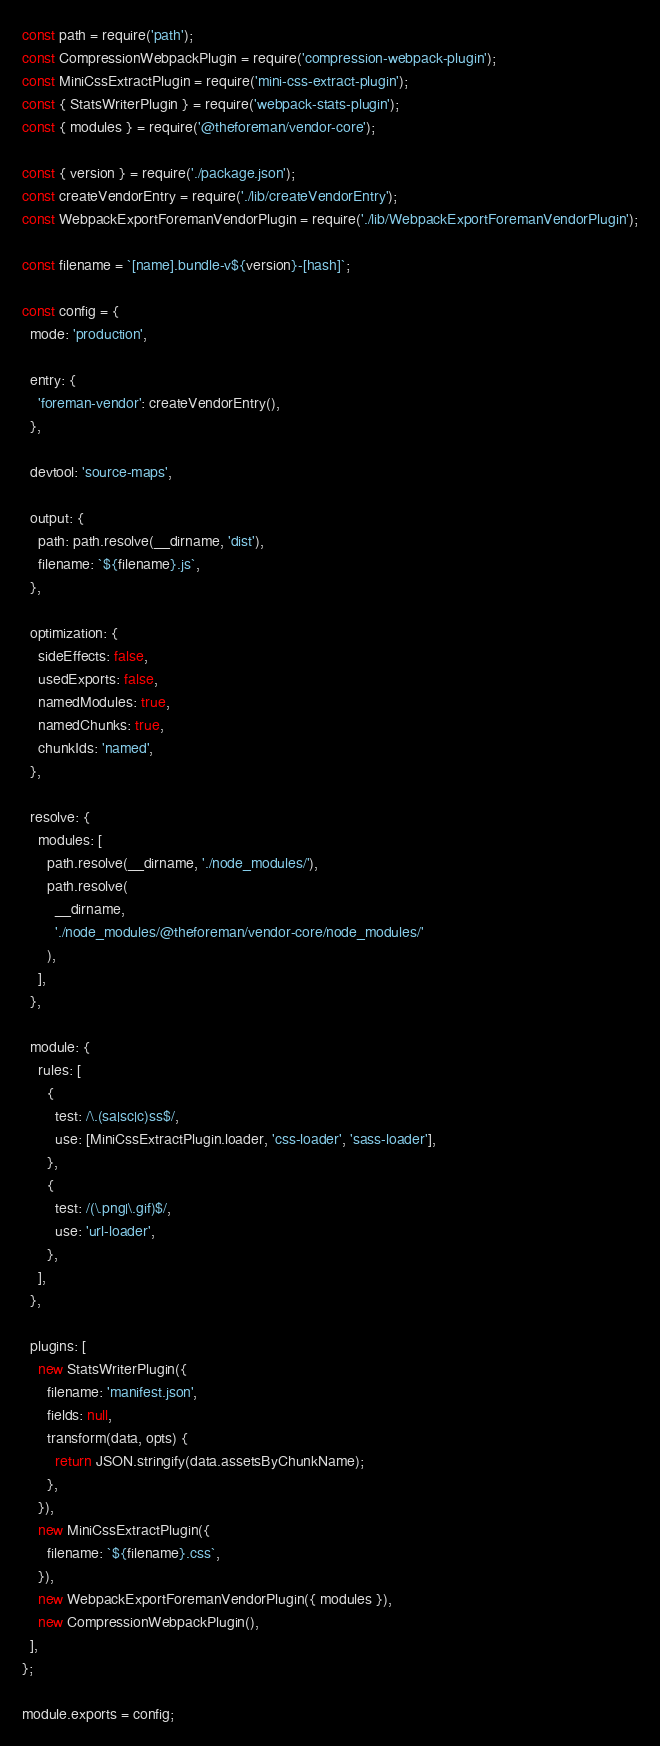<code> <loc_0><loc_0><loc_500><loc_500><_JavaScript_>const path = require('path');
const CompressionWebpackPlugin = require('compression-webpack-plugin');
const MiniCssExtractPlugin = require('mini-css-extract-plugin');
const { StatsWriterPlugin } = require('webpack-stats-plugin');
const { modules } = require('@theforeman/vendor-core');

const { version } = require('./package.json');
const createVendorEntry = require('./lib/createVendorEntry');
const WebpackExportForemanVendorPlugin = require('./lib/WebpackExportForemanVendorPlugin');

const filename = `[name].bundle-v${version}-[hash]`;

const config = {
  mode: 'production',

  entry: {
    'foreman-vendor': createVendorEntry(),
  },

  devtool: 'source-maps',

  output: {
    path: path.resolve(__dirname, 'dist'),
    filename: `${filename}.js`,
  },

  optimization: {
    sideEffects: false,
    usedExports: false,
    namedModules: true,
    namedChunks: true,
    chunkIds: 'named',
  },

  resolve: {
    modules: [
      path.resolve(__dirname, './node_modules/'),
      path.resolve(
        __dirname,
        './node_modules/@theforeman/vendor-core/node_modules/'
      ),
    ],
  },

  module: {
    rules: [
      {
        test: /\.(sa|sc|c)ss$/,
        use: [MiniCssExtractPlugin.loader, 'css-loader', 'sass-loader'],
      },
      {
        test: /(\.png|\.gif)$/,
        use: 'url-loader',
      },
    ],
  },

  plugins: [
    new StatsWriterPlugin({
      filename: 'manifest.json',
      fields: null,
      transform(data, opts) {
        return JSON.stringify(data.assetsByChunkName);
      },
    }),
    new MiniCssExtractPlugin({
      filename: `${filename}.css`,
    }),
    new WebpackExportForemanVendorPlugin({ modules }),
    new CompressionWebpackPlugin(),
  ],
};

module.exports = config;
</code> 